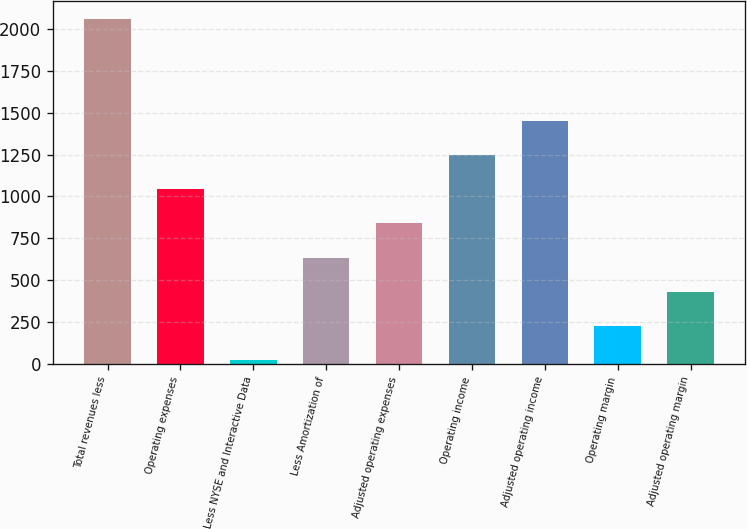Convert chart. <chart><loc_0><loc_0><loc_500><loc_500><bar_chart><fcel>Total revenues less<fcel>Operating expenses<fcel>Less NYSE and Interactive Data<fcel>Less Amortization of<fcel>Adjusted operating expenses<fcel>Operating income<fcel>Adjusted operating income<fcel>Operating margin<fcel>Adjusted operating margin<nl><fcel>2062<fcel>1043<fcel>24<fcel>635.4<fcel>839.2<fcel>1246.8<fcel>1450.6<fcel>227.8<fcel>431.6<nl></chart> 